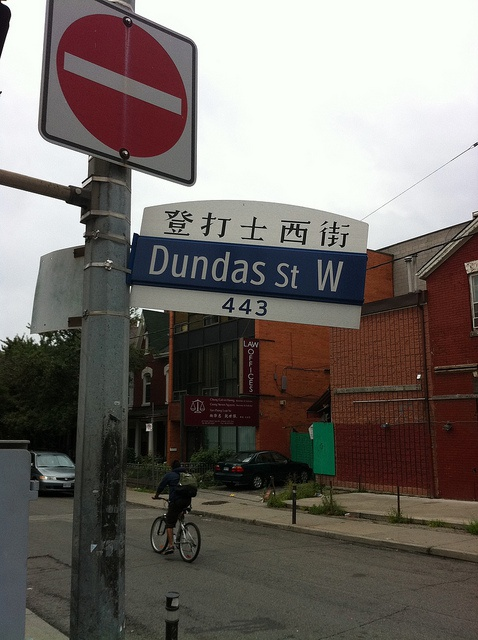Describe the objects in this image and their specific colors. I can see car in black, gray, and maroon tones, car in black, gray, and darkgray tones, bicycle in black, gray, and darkgray tones, people in black, maroon, and gray tones, and backpack in black, darkgreen, and gray tones in this image. 